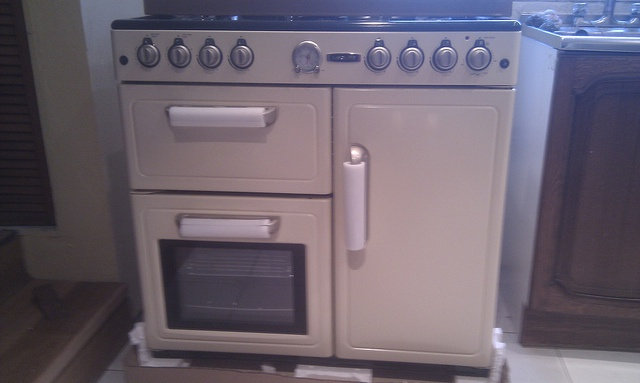Describe the objects in this image and their specific colors. I can see oven in black, darkgray, and gray tones and sink in black, gray, and darkgray tones in this image. 